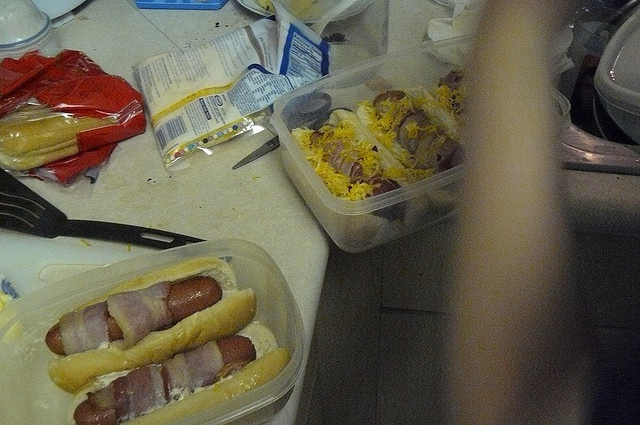Describe the objects in this image and their specific colors. I can see people in darkgray, gray, and black tones, bowl in darkgray, olive, gray, and maroon tones, bowl in darkgray, gray, olive, and black tones, hot dog in darkgray, olive, gray, and maroon tones, and hot dog in darkgray, gray, maroon, and black tones in this image. 